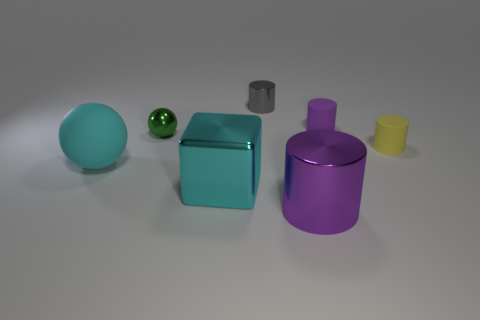Is the color of the metallic cube the same as the big cylinder?
Keep it short and to the point. No. What size is the purple thing that is on the left side of the tiny purple thing?
Your answer should be very brief. Large. Do the yellow thing and the gray cylinder have the same material?
Provide a short and direct response. No. What is the shape of the green thing that is the same material as the big cyan cube?
Ensure brevity in your answer.  Sphere. Is there any other thing that has the same color as the shiny block?
Your answer should be very brief. Yes. What color is the tiny metal thing left of the small gray metallic thing?
Ensure brevity in your answer.  Green. There is a small metal thing on the left side of the gray metallic object; does it have the same color as the large metal block?
Give a very brief answer. No. What is the material of the other purple thing that is the same shape as the big purple metallic object?
Give a very brief answer. Rubber. How many green spheres have the same size as the cyan matte object?
Provide a succinct answer. 0. What is the shape of the green thing?
Your answer should be compact. Sphere. 